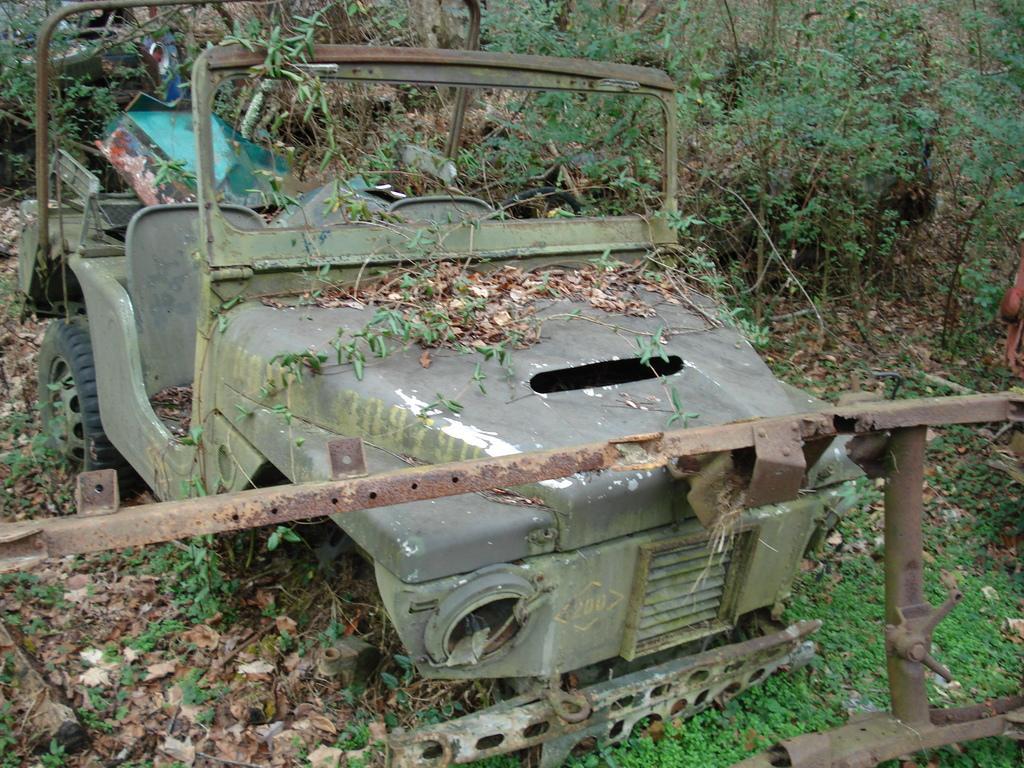Could you give a brief overview of what you see in this image? In this image we can see a damaged vehicle on the ground, there is a metal rod in front of the vehicle and there are few objects in the vehicle and there are few trees an plants in the background. 